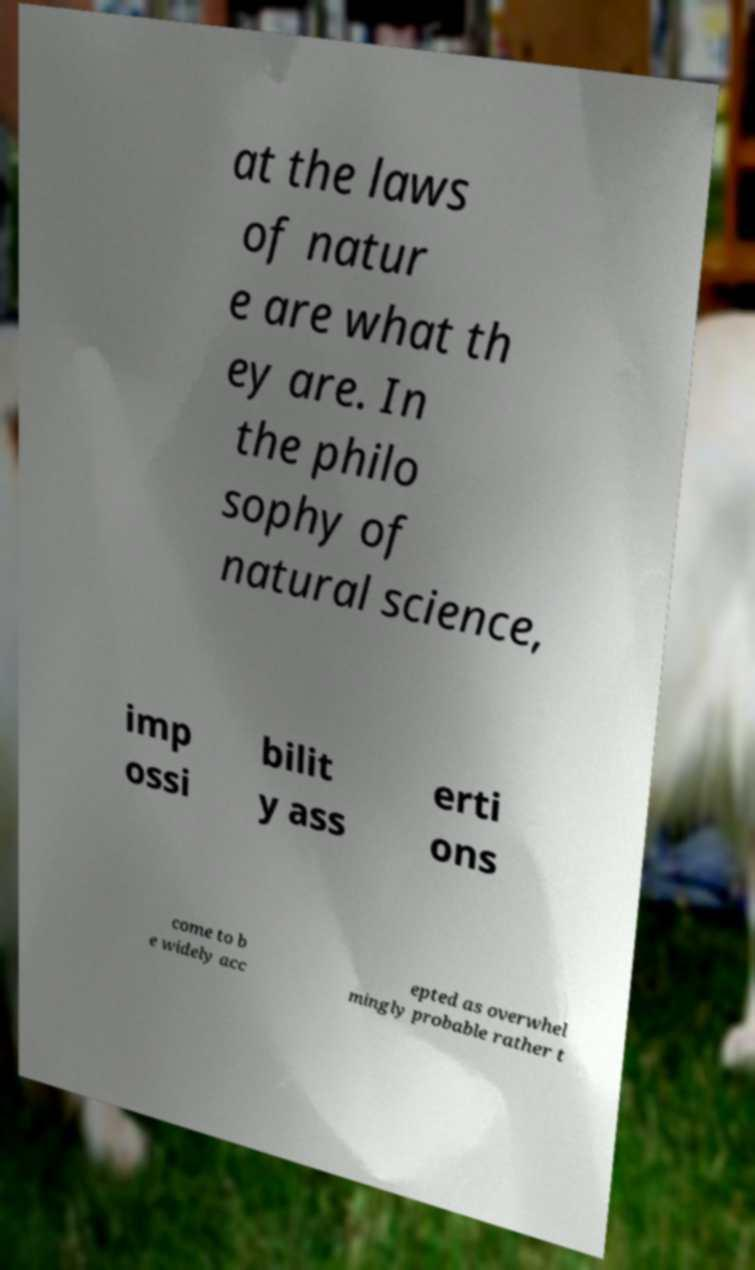Can you read and provide the text displayed in the image?This photo seems to have some interesting text. Can you extract and type it out for me? at the laws of natur e are what th ey are. In the philo sophy of natural science, imp ossi bilit y ass erti ons come to b e widely acc epted as overwhel mingly probable rather t 